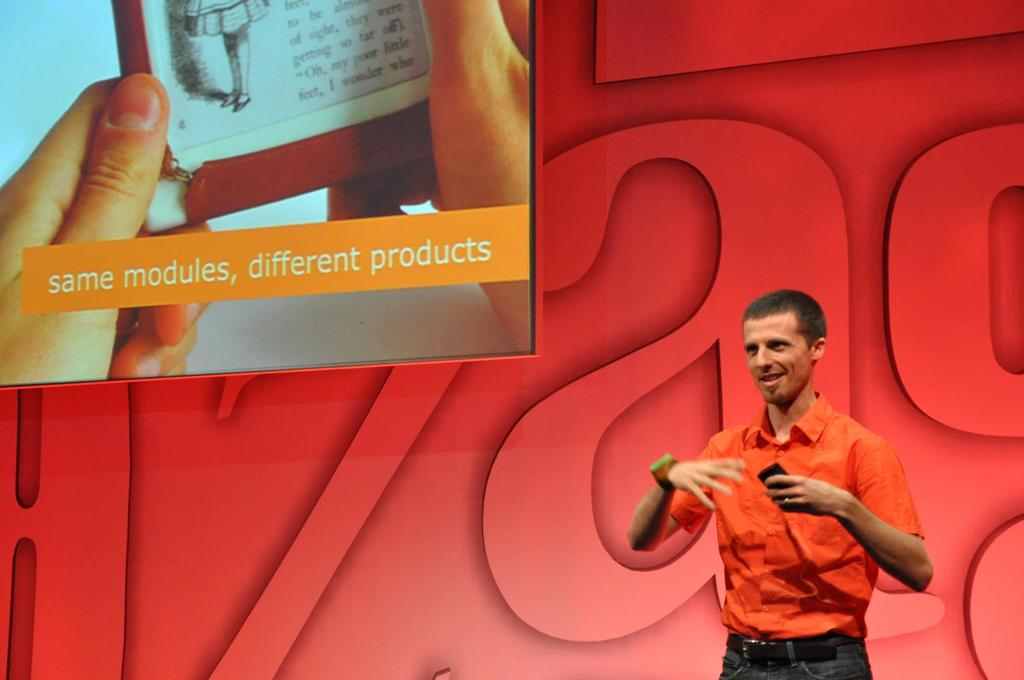Provide a one-sentence caption for the provided image. A presenter dressed in an orange shirt enthusiastically explains a concept, highlighted by the displayed message 'same modules, different products,' which could imply a discussion on adaptable technology or product versatility. 